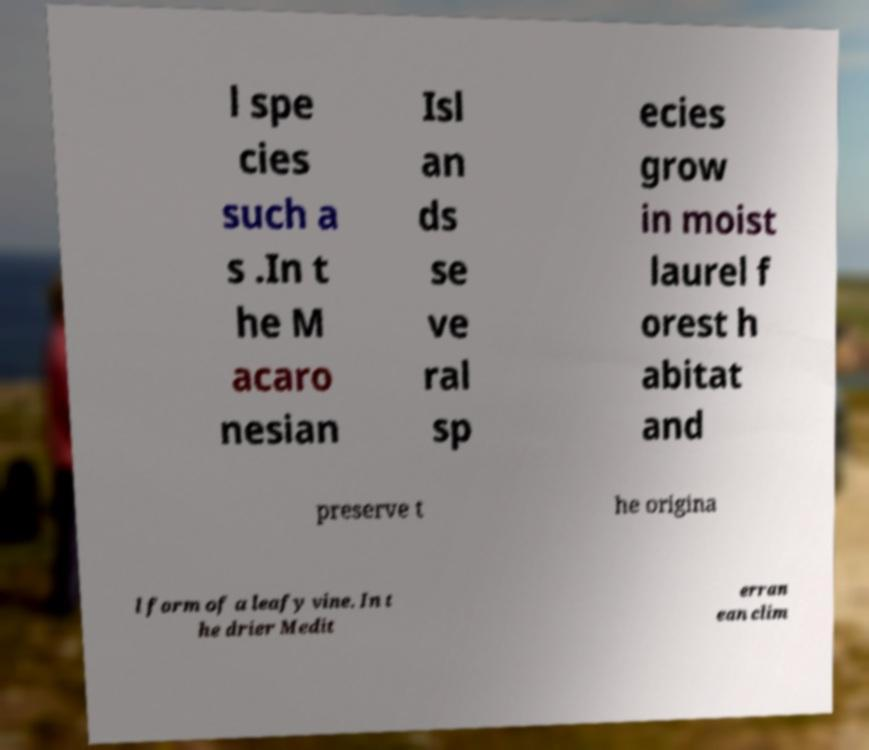For documentation purposes, I need the text within this image transcribed. Could you provide that? l spe cies such a s .In t he M acaro nesian Isl an ds se ve ral sp ecies grow in moist laurel f orest h abitat and preserve t he origina l form of a leafy vine. In t he drier Medit erran ean clim 